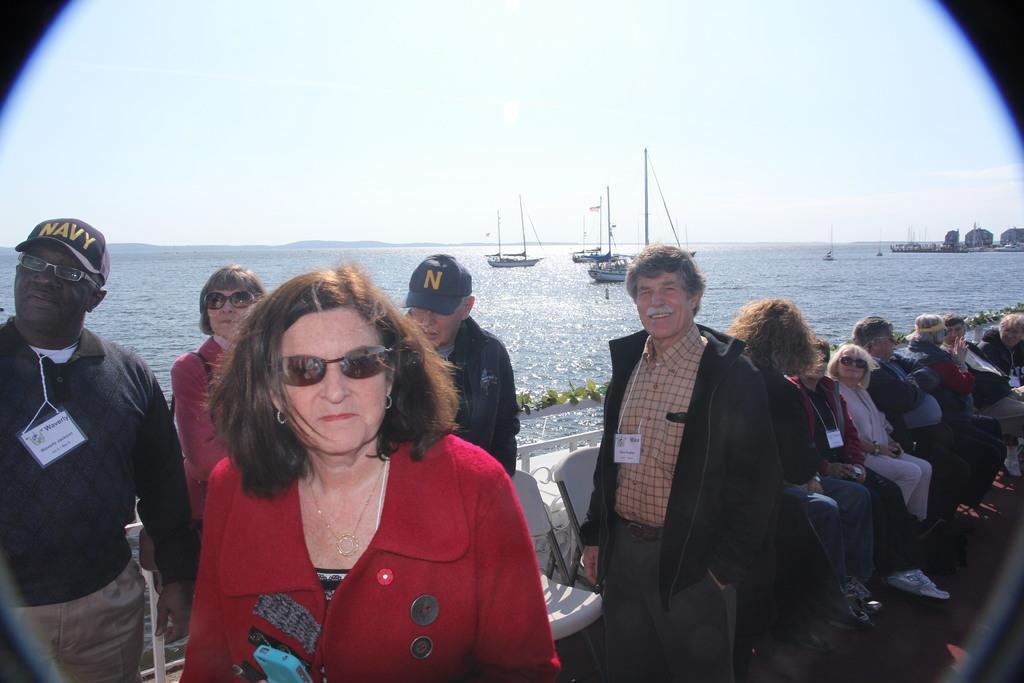Can you describe this image briefly? In this picture I can see there are few people sitting on the chairs and some of them are standing and there is a ocean in the backdrop and the sky is clear. 